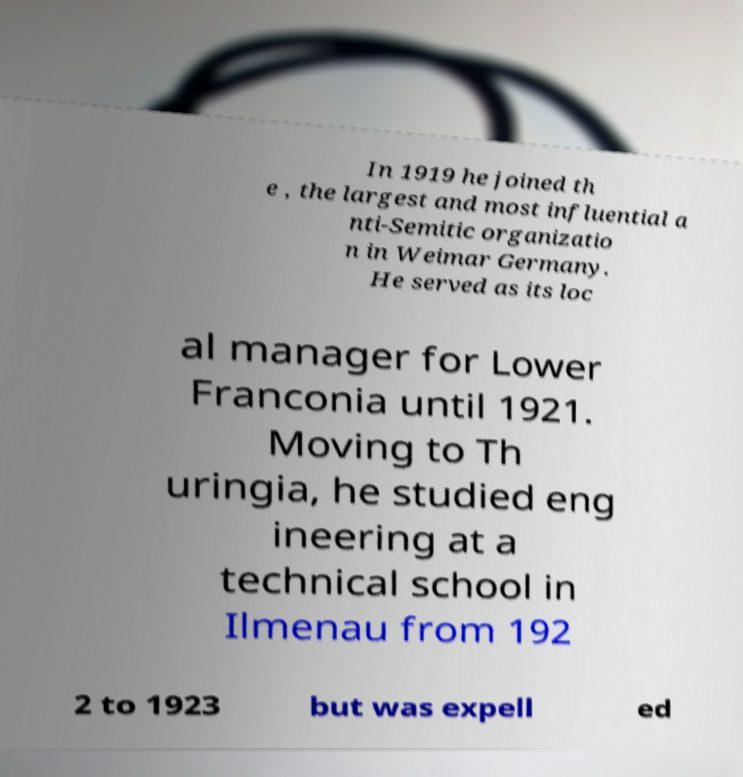Can you accurately transcribe the text from the provided image for me? In 1919 he joined th e , the largest and most influential a nti-Semitic organizatio n in Weimar Germany. He served as its loc al manager for Lower Franconia until 1921. Moving to Th uringia, he studied eng ineering at a technical school in Ilmenau from 192 2 to 1923 but was expell ed 